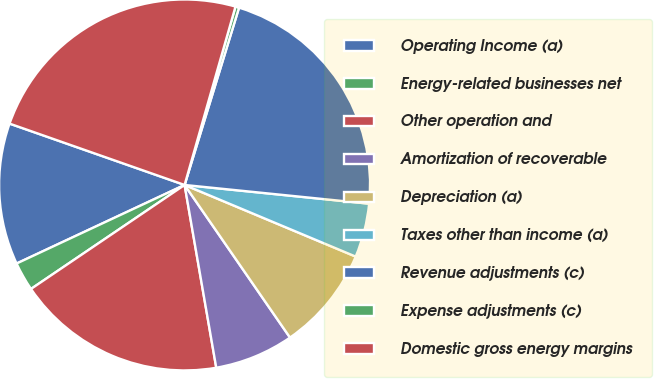Convert chart to OTSL. <chart><loc_0><loc_0><loc_500><loc_500><pie_chart><fcel>Operating Income (a)<fcel>Energy-related businesses net<fcel>Other operation and<fcel>Amortization of recoverable<fcel>Depreciation (a)<fcel>Taxes other than income (a)<fcel>Revenue adjustments (c)<fcel>Expense adjustments (c)<fcel>Domestic gross energy margins<nl><fcel>12.33%<fcel>2.51%<fcel>18.26%<fcel>6.89%<fcel>9.07%<fcel>4.7%<fcel>21.87%<fcel>0.32%<fcel>24.06%<nl></chart> 